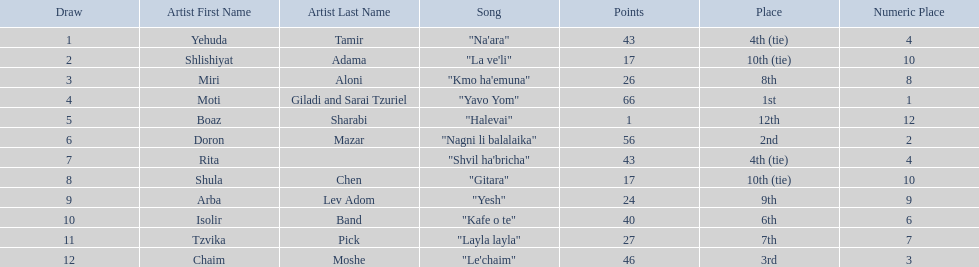What are the points? 43, 17, 26, 66, 1, 56, 43, 17, 24, 40, 27, 46. What is the least? 1. Which artist has that much Boaz Sharabi. 